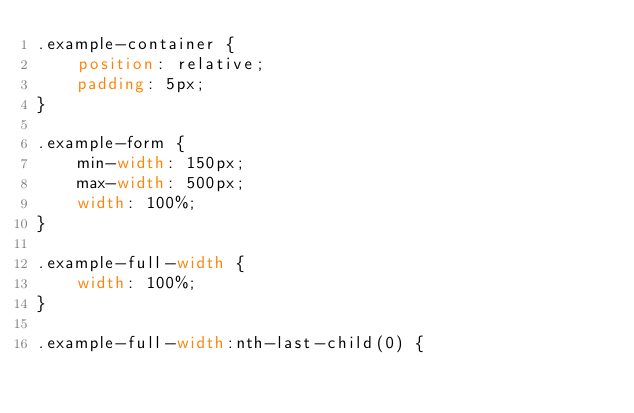Convert code to text. <code><loc_0><loc_0><loc_500><loc_500><_CSS_>.example-container {
    position: relative;
    padding: 5px;
}

.example-form {
    min-width: 150px;
    max-width: 500px;
    width: 100%;
}

.example-full-width {
    width: 100%;
}

.example-full-width:nth-last-child(0) {</code> 